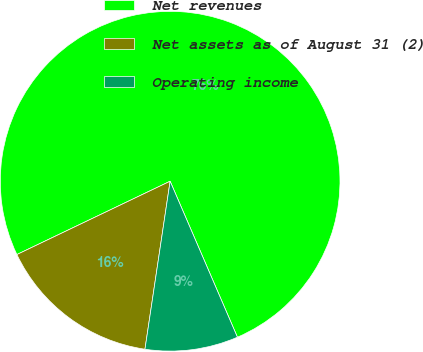Convert chart to OTSL. <chart><loc_0><loc_0><loc_500><loc_500><pie_chart><fcel>Net revenues<fcel>Net assets as of August 31 (2)<fcel>Operating income<nl><fcel>75.62%<fcel>15.53%<fcel>8.85%<nl></chart> 